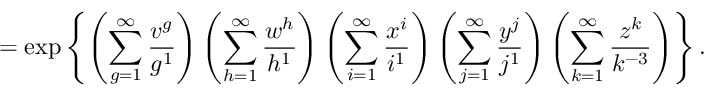Convert formula to latex. <formula><loc_0><loc_0><loc_500><loc_500>= \exp \left \{ \left ( \sum _ { g = 1 } ^ { \infty } \frac { v ^ { g } } { g ^ { 1 } } \right ) \left ( \sum _ { h = 1 } ^ { \infty } \frac { w ^ { h } } { h ^ { 1 } } \right ) \left ( \sum _ { i = 1 } ^ { \infty } \frac { x ^ { i } } { i ^ { 1 } } \right ) \left ( \sum _ { j = 1 } ^ { \infty } \frac { y ^ { j } } { j ^ { 1 } } \right ) \left ( \sum _ { k = 1 } ^ { \infty } \frac { z ^ { k } } { k ^ { - 3 } } \right ) \right \} .</formula> 